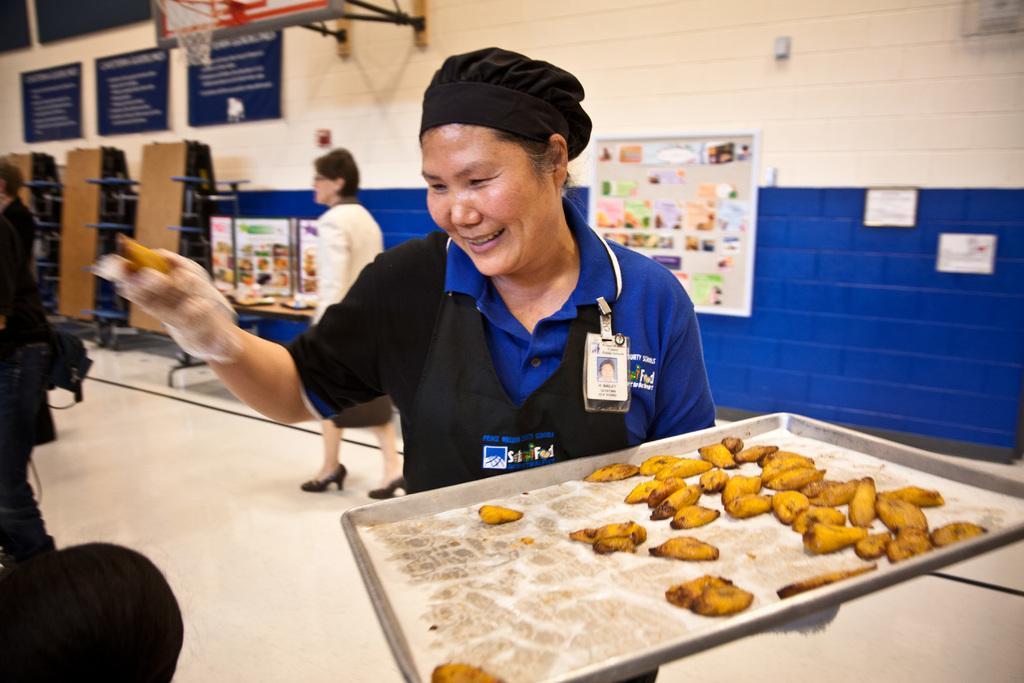How would you summarize this image in a sentence or two? In this image we can see a group of people standing on the floor. One woman is wearing a cap and holding tray containing food. In the background, we can see group of posters, photos, boards with some text, a goal post, some racks placed on stands and some objects placed on the table. 